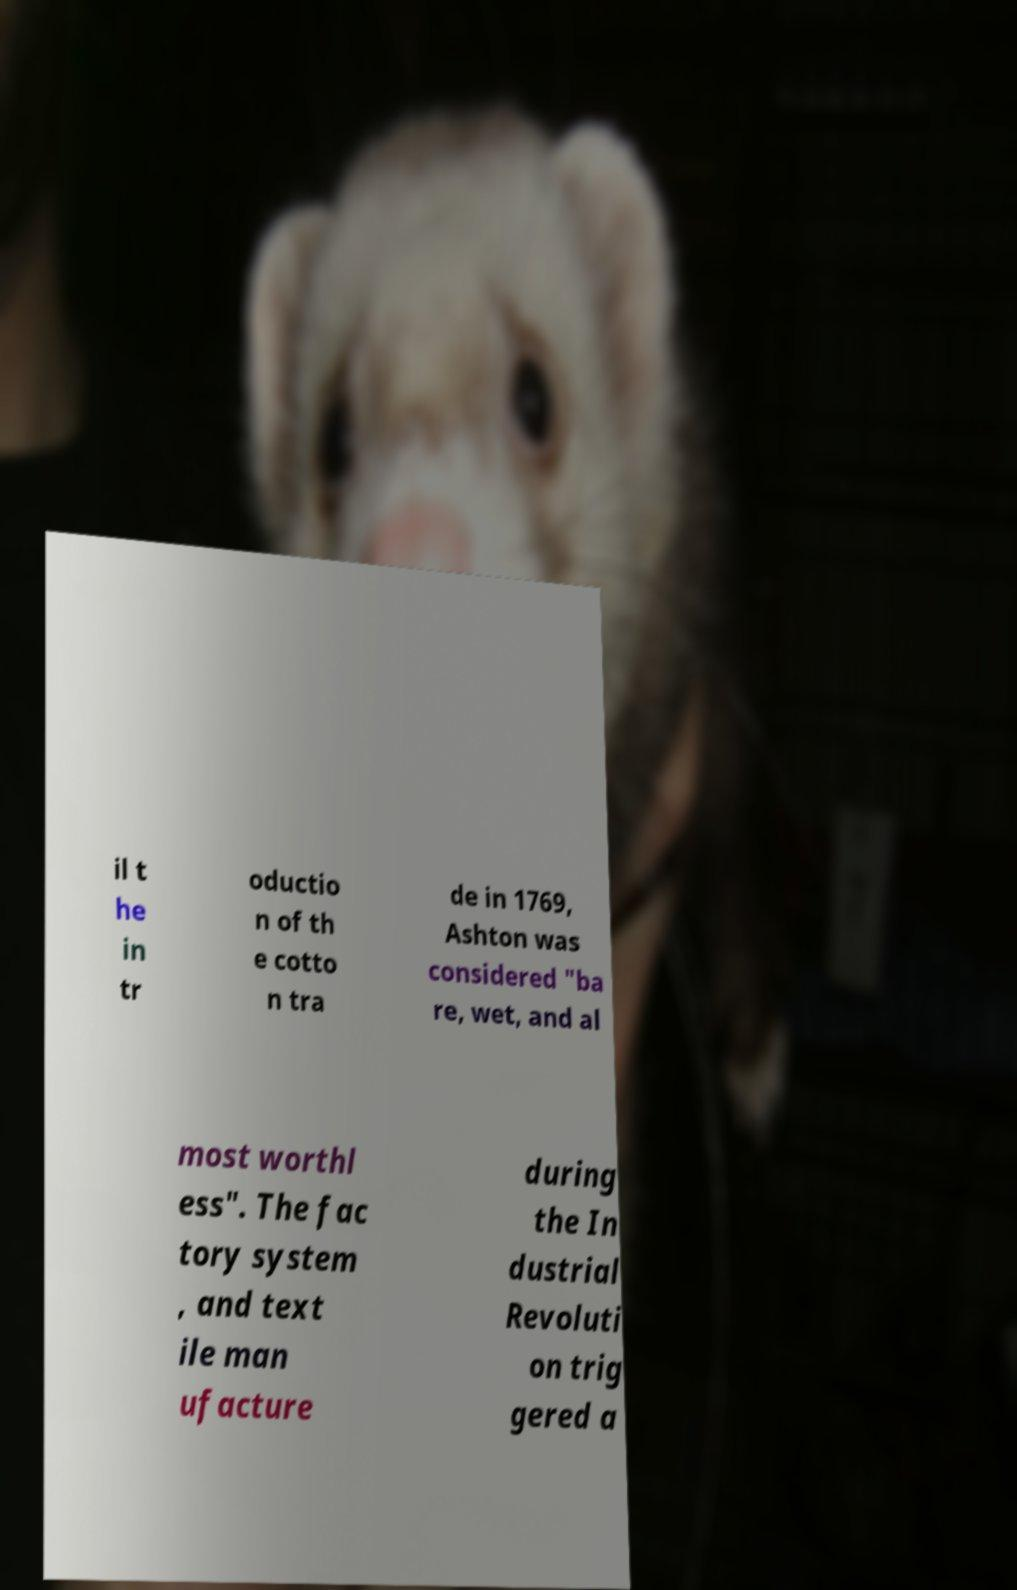I need the written content from this picture converted into text. Can you do that? il t he in tr oductio n of th e cotto n tra de in 1769, Ashton was considered "ba re, wet, and al most worthl ess". The fac tory system , and text ile man ufacture during the In dustrial Revoluti on trig gered a 